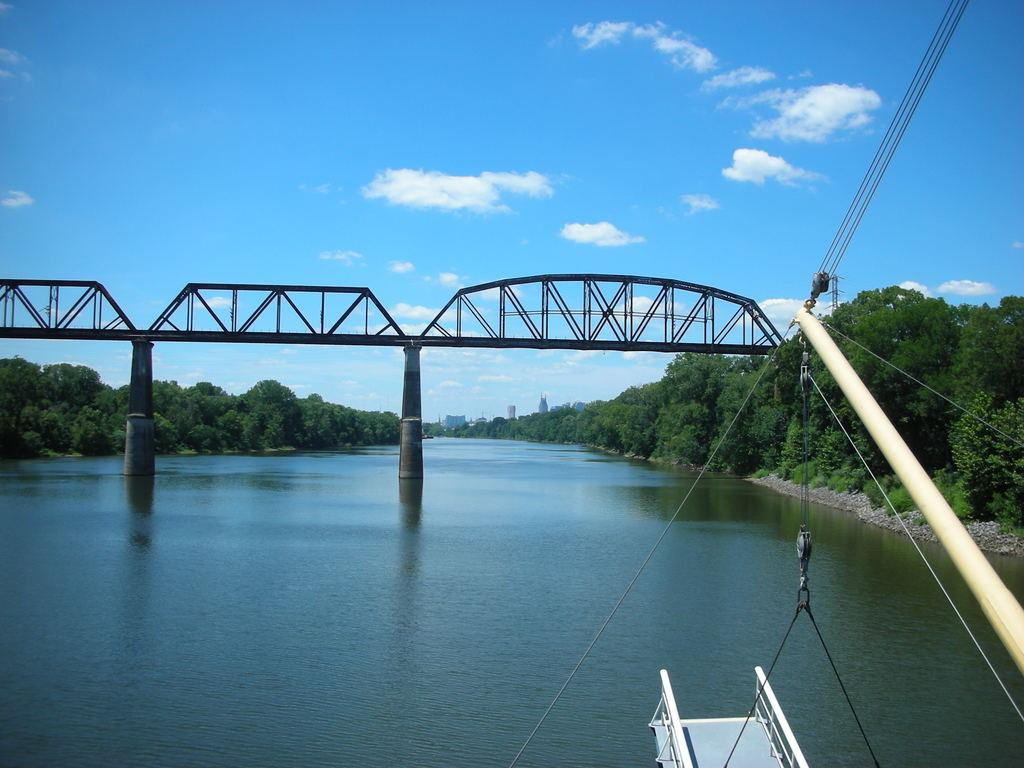What is at the bottom of the image? There is water at the bottom of the image. What structure is located in the middle of the image? There is a bridge in the middle of the image. What type of vegetation is on either side of the water? There are trees on either side of the water. What color is the sky in the image? The sky is blue at the top of the image. Where is the pancake being served to the queen and her army in the image? There is no pancake, queen, or army present in the image. 